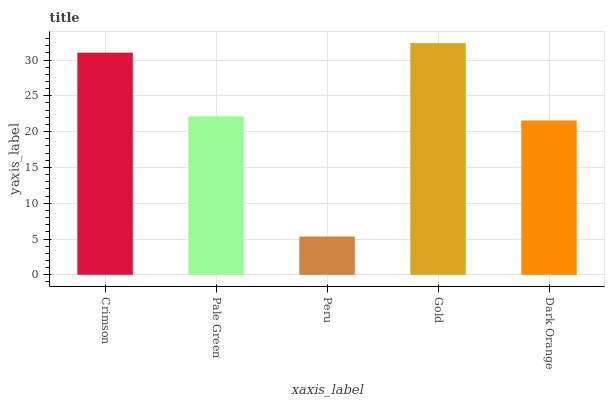Is Peru the minimum?
Answer yes or no. Yes. Is Gold the maximum?
Answer yes or no. Yes. Is Pale Green the minimum?
Answer yes or no. No. Is Pale Green the maximum?
Answer yes or no. No. Is Crimson greater than Pale Green?
Answer yes or no. Yes. Is Pale Green less than Crimson?
Answer yes or no. Yes. Is Pale Green greater than Crimson?
Answer yes or no. No. Is Crimson less than Pale Green?
Answer yes or no. No. Is Pale Green the high median?
Answer yes or no. Yes. Is Pale Green the low median?
Answer yes or no. Yes. Is Peru the high median?
Answer yes or no. No. Is Peru the low median?
Answer yes or no. No. 